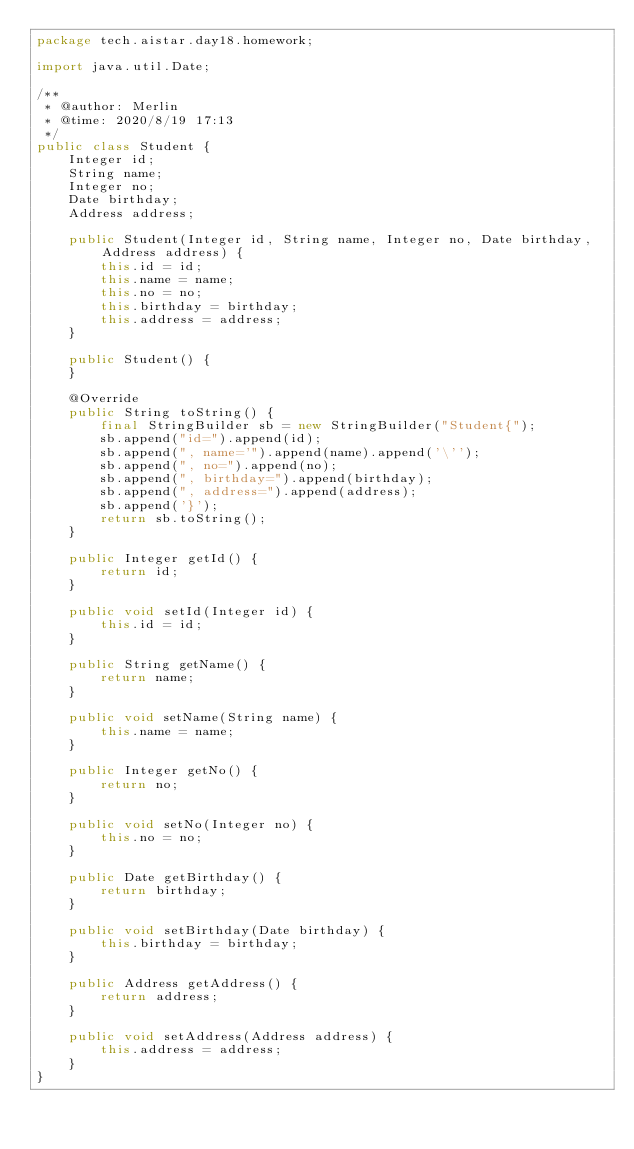Convert code to text. <code><loc_0><loc_0><loc_500><loc_500><_Java_>package tech.aistar.day18.homework;

import java.util.Date;

/**
 * @author: Merlin
 * @time: 2020/8/19 17:13
 */
public class Student {
    Integer id;
    String name;
    Integer no;
    Date birthday;
    Address address;

    public Student(Integer id, String name, Integer no, Date birthday, Address address) {
        this.id = id;
        this.name = name;
        this.no = no;
        this.birthday = birthday;
        this.address = address;
    }

    public Student() {
    }

    @Override
    public String toString() {
        final StringBuilder sb = new StringBuilder("Student{");
        sb.append("id=").append(id);
        sb.append(", name='").append(name).append('\'');
        sb.append(", no=").append(no);
        sb.append(", birthday=").append(birthday);
        sb.append(", address=").append(address);
        sb.append('}');
        return sb.toString();
    }

    public Integer getId() {
        return id;
    }

    public void setId(Integer id) {
        this.id = id;
    }

    public String getName() {
        return name;
    }

    public void setName(String name) {
        this.name = name;
    }

    public Integer getNo() {
        return no;
    }

    public void setNo(Integer no) {
        this.no = no;
    }

    public Date getBirthday() {
        return birthday;
    }

    public void setBirthday(Date birthday) {
        this.birthday = birthday;
    }

    public Address getAddress() {
        return address;
    }

    public void setAddress(Address address) {
        this.address = address;
    }
}

</code> 